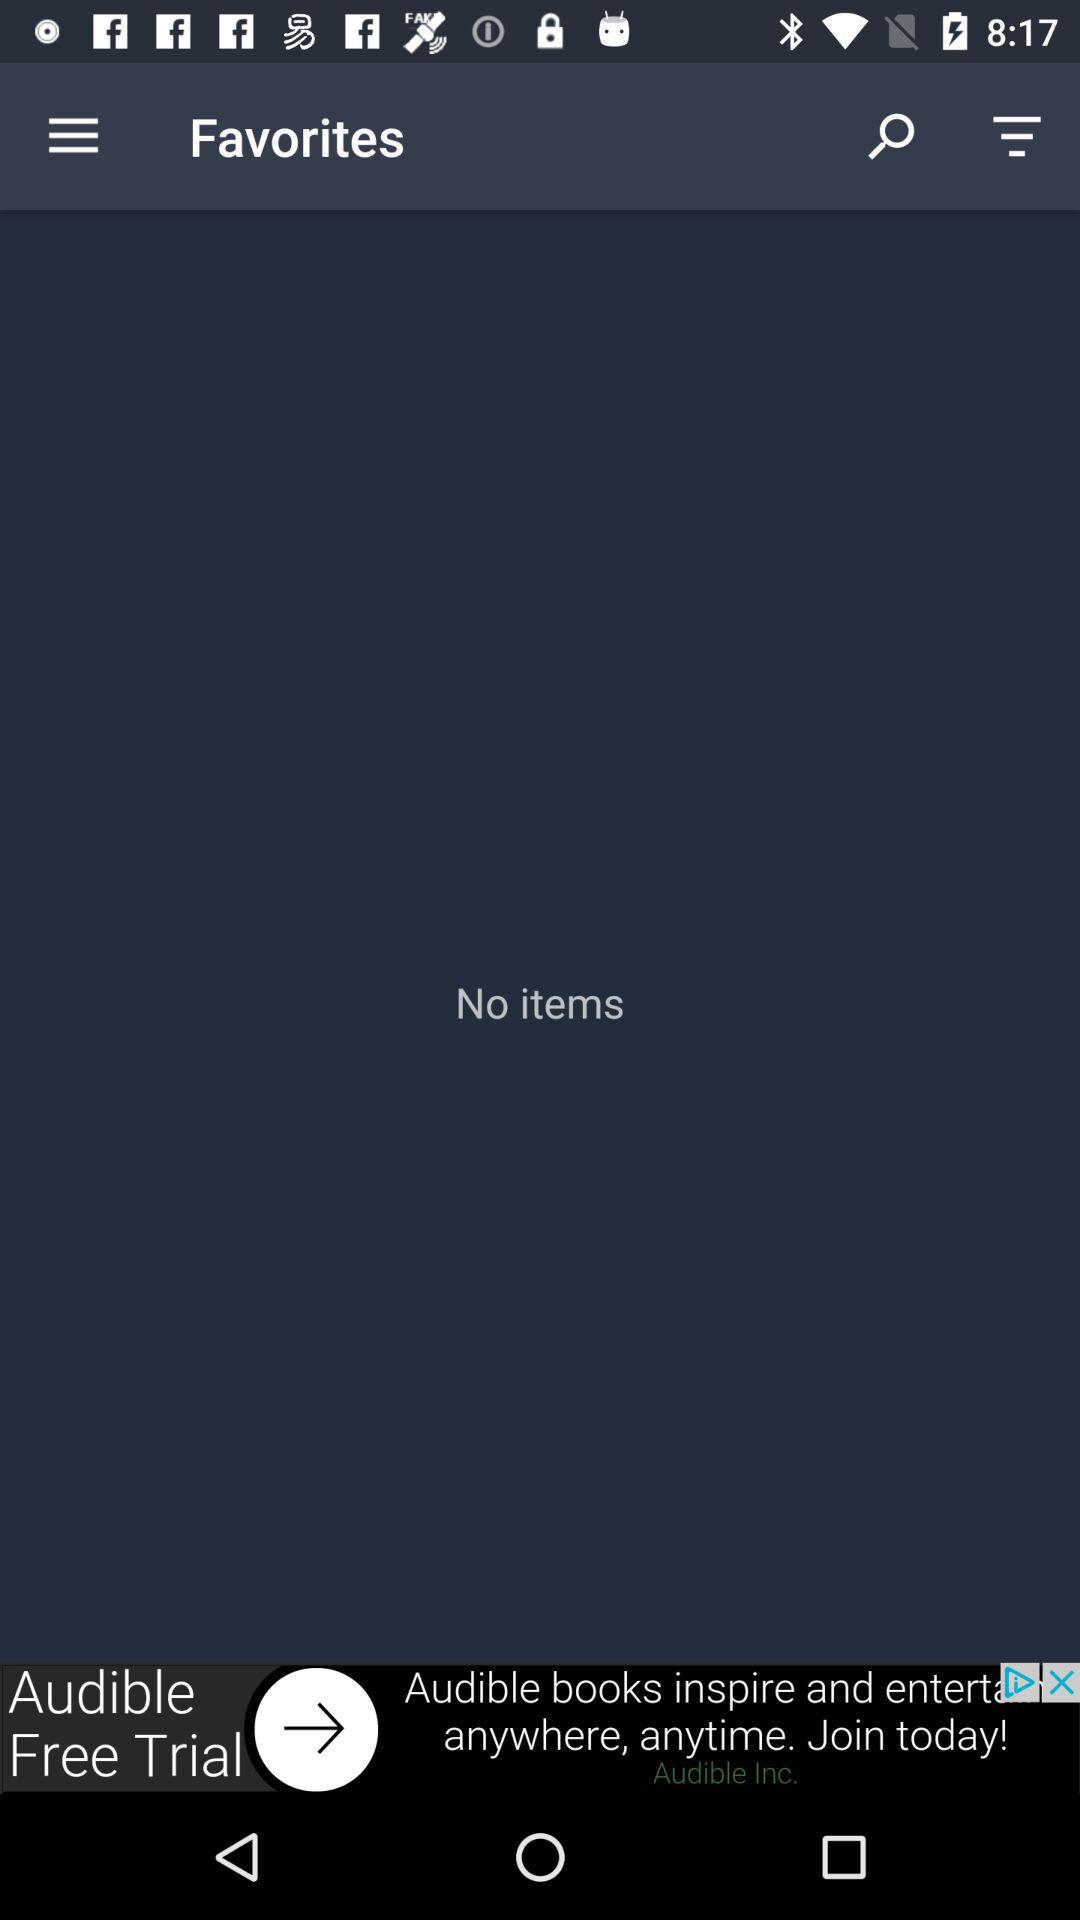Is there any item? There is no item. 